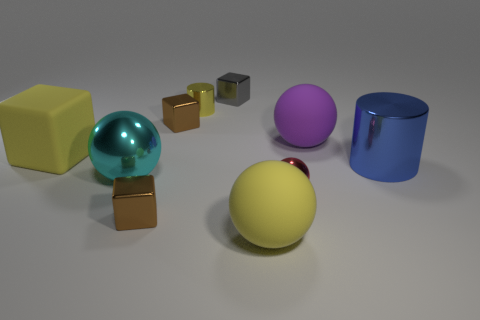Subtract 1 balls. How many balls are left? 3 Subtract all green balls. Subtract all purple blocks. How many balls are left? 4 Subtract all cylinders. How many objects are left? 8 Add 1 big purple things. How many big purple things are left? 2 Add 6 tiny cylinders. How many tiny cylinders exist? 7 Subtract 0 red cubes. How many objects are left? 10 Subtract all yellow shiny things. Subtract all small shiny cubes. How many objects are left? 6 